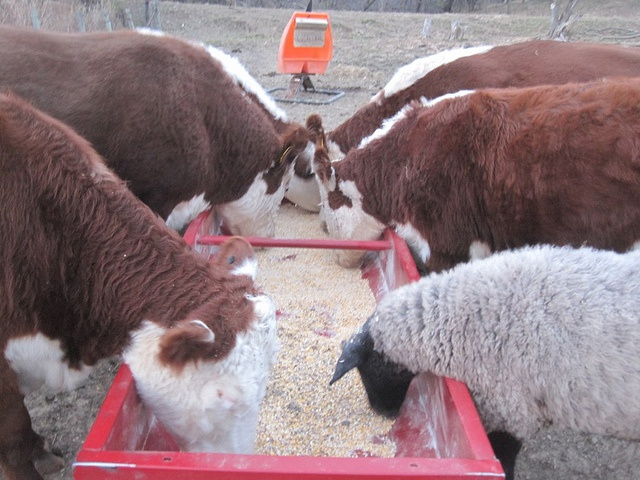Describe the objects in this image and their specific colors. I can see cow in gray, black, and lightgray tones, cow in gray, maroon, brown, and black tones, sheep in gray, darkgray, lavender, and black tones, cow in gray, black, and darkgray tones, and cow in gray, brown, darkgray, and white tones in this image. 